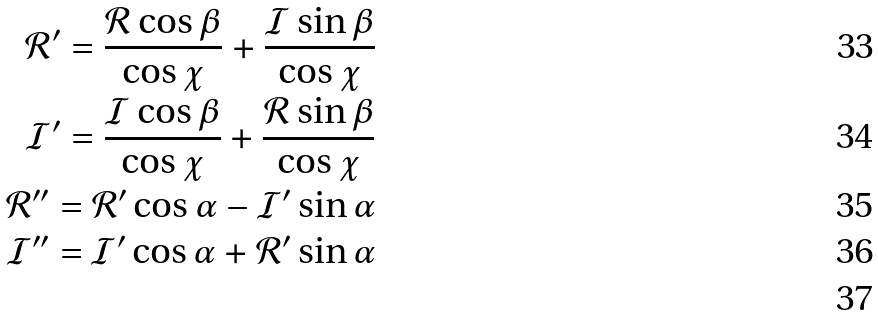<formula> <loc_0><loc_0><loc_500><loc_500>\mathcal { R } ^ { \prime } = \frac { \mathcal { R } \cos \beta } { \cos { \chi } } + \frac { \mathcal { I } \sin { \beta } } { \cos { \chi } } \\ \mathcal { I } ^ { \prime } = \frac { \mathcal { I } \cos \beta } { \cos { \chi } } + \frac { \mathcal { R } \sin { \beta } } { \cos { \chi } } \\ \mathcal { R } ^ { \prime \prime } = \mathcal { R } ^ { \prime } \cos { \alpha } - \mathcal { I } ^ { \prime } \sin { \alpha } \\ \mathcal { I } ^ { \prime \prime } = \mathcal { I } ^ { \prime } \cos { \alpha } + \mathcal { R } ^ { \prime } \sin { \alpha } \\</formula> 